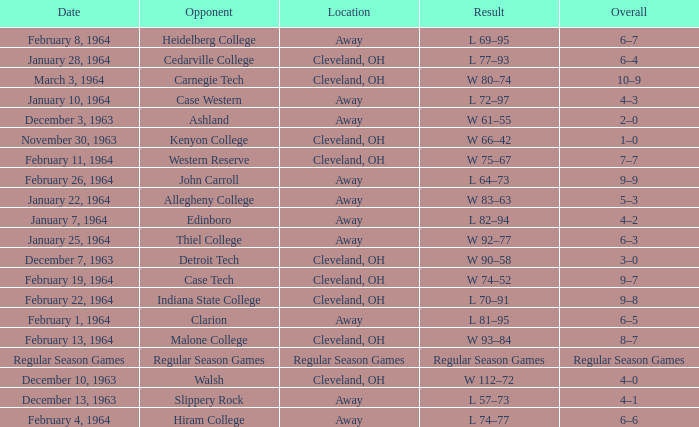What is the Date with an Opponent that is indiana state college? February 22, 1964. 